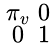<formula> <loc_0><loc_0><loc_500><loc_500>\begin{smallmatrix} \pi _ { v } & 0 \\ 0 & 1 \end{smallmatrix}</formula> 